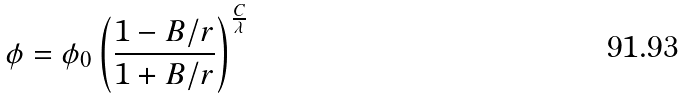Convert formula to latex. <formula><loc_0><loc_0><loc_500><loc_500>\phi = \phi _ { 0 } \left ( \frac { 1 - B / r } { 1 + B / r } \right ) ^ { \frac { C } { \lambda } }</formula> 